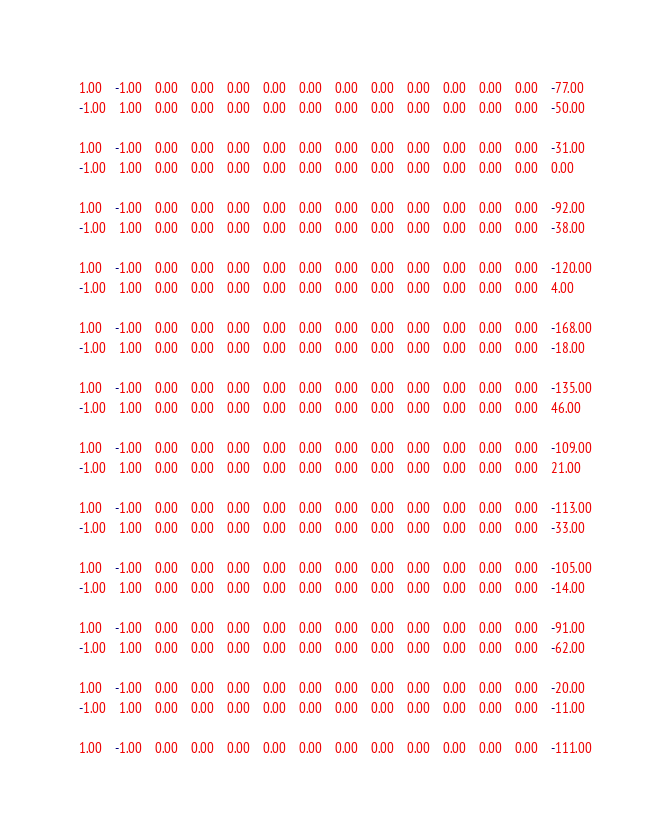Convert code to text. <code><loc_0><loc_0><loc_500><loc_500><_Matlab_>1.00	-1.00	0.00	0.00	0.00	0.00	0.00	0.00	0.00	0.00	0.00	0.00	0.00	-77.00
-1.00	1.00	0.00	0.00	0.00	0.00	0.00	0.00	0.00	0.00	0.00	0.00	0.00	-50.00

1.00	-1.00	0.00	0.00	0.00	0.00	0.00	0.00	0.00	0.00	0.00	0.00	0.00	-31.00
-1.00	1.00	0.00	0.00	0.00	0.00	0.00	0.00	0.00	0.00	0.00	0.00	0.00	0.00

1.00	-1.00	0.00	0.00	0.00	0.00	0.00	0.00	0.00	0.00	0.00	0.00	0.00	-92.00
-1.00	1.00	0.00	0.00	0.00	0.00	0.00	0.00	0.00	0.00	0.00	0.00	0.00	-38.00

1.00	-1.00	0.00	0.00	0.00	0.00	0.00	0.00	0.00	0.00	0.00	0.00	0.00	-120.00
-1.00	1.00	0.00	0.00	0.00	0.00	0.00	0.00	0.00	0.00	0.00	0.00	0.00	4.00

1.00	-1.00	0.00	0.00	0.00	0.00	0.00	0.00	0.00	0.00	0.00	0.00	0.00	-168.00
-1.00	1.00	0.00	0.00	0.00	0.00	0.00	0.00	0.00	0.00	0.00	0.00	0.00	-18.00

1.00	-1.00	0.00	0.00	0.00	0.00	0.00	0.00	0.00	0.00	0.00	0.00	0.00	-135.00
-1.00	1.00	0.00	0.00	0.00	0.00	0.00	0.00	0.00	0.00	0.00	0.00	0.00	46.00

1.00	-1.00	0.00	0.00	0.00	0.00	0.00	0.00	0.00	0.00	0.00	0.00	0.00	-109.00
-1.00	1.00	0.00	0.00	0.00	0.00	0.00	0.00	0.00	0.00	0.00	0.00	0.00	21.00

1.00	-1.00	0.00	0.00	0.00	0.00	0.00	0.00	0.00	0.00	0.00	0.00	0.00	-113.00
-1.00	1.00	0.00	0.00	0.00	0.00	0.00	0.00	0.00	0.00	0.00	0.00	0.00	-33.00

1.00	-1.00	0.00	0.00	0.00	0.00	0.00	0.00	0.00	0.00	0.00	0.00	0.00	-105.00
-1.00	1.00	0.00	0.00	0.00	0.00	0.00	0.00	0.00	0.00	0.00	0.00	0.00	-14.00

1.00	-1.00	0.00	0.00	0.00	0.00	0.00	0.00	0.00	0.00	0.00	0.00	0.00	-91.00
-1.00	1.00	0.00	0.00	0.00	0.00	0.00	0.00	0.00	0.00	0.00	0.00	0.00	-62.00

1.00	-1.00	0.00	0.00	0.00	0.00	0.00	0.00	0.00	0.00	0.00	0.00	0.00	-20.00
-1.00	1.00	0.00	0.00	0.00	0.00	0.00	0.00	0.00	0.00	0.00	0.00	0.00	-11.00

1.00	-1.00	0.00	0.00	0.00	0.00	0.00	0.00	0.00	0.00	0.00	0.00	0.00	-111.00</code> 